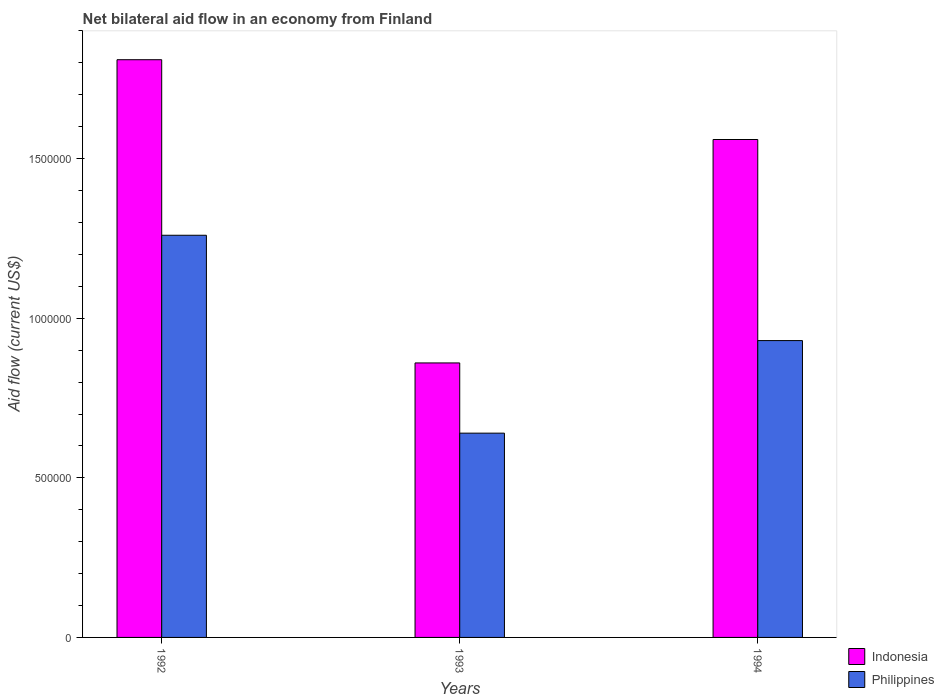How many different coloured bars are there?
Your answer should be very brief. 2. Are the number of bars on each tick of the X-axis equal?
Make the answer very short. Yes. How many bars are there on the 3rd tick from the left?
Offer a very short reply. 2. How many bars are there on the 2nd tick from the right?
Your answer should be compact. 2. What is the label of the 1st group of bars from the left?
Your answer should be very brief. 1992. What is the net bilateral aid flow in Indonesia in 1994?
Provide a succinct answer. 1.56e+06. Across all years, what is the maximum net bilateral aid flow in Philippines?
Your answer should be very brief. 1.26e+06. Across all years, what is the minimum net bilateral aid flow in Indonesia?
Make the answer very short. 8.60e+05. In which year was the net bilateral aid flow in Philippines minimum?
Offer a very short reply. 1993. What is the total net bilateral aid flow in Indonesia in the graph?
Give a very brief answer. 4.23e+06. What is the difference between the net bilateral aid flow in Philippines in 1992 and that in 1993?
Give a very brief answer. 6.20e+05. What is the average net bilateral aid flow in Indonesia per year?
Give a very brief answer. 1.41e+06. In the year 1993, what is the difference between the net bilateral aid flow in Philippines and net bilateral aid flow in Indonesia?
Offer a terse response. -2.20e+05. What is the ratio of the net bilateral aid flow in Indonesia in 1992 to that in 1994?
Provide a short and direct response. 1.16. Is the difference between the net bilateral aid flow in Philippines in 1993 and 1994 greater than the difference between the net bilateral aid flow in Indonesia in 1993 and 1994?
Your answer should be compact. Yes. What is the difference between the highest and the second highest net bilateral aid flow in Philippines?
Your answer should be very brief. 3.30e+05. What is the difference between the highest and the lowest net bilateral aid flow in Philippines?
Keep it short and to the point. 6.20e+05. In how many years, is the net bilateral aid flow in Philippines greater than the average net bilateral aid flow in Philippines taken over all years?
Your answer should be compact. 1. Is the sum of the net bilateral aid flow in Philippines in 1992 and 1993 greater than the maximum net bilateral aid flow in Indonesia across all years?
Your response must be concise. Yes. What does the 1st bar from the right in 1993 represents?
Offer a terse response. Philippines. How many bars are there?
Your answer should be compact. 6. Are the values on the major ticks of Y-axis written in scientific E-notation?
Your response must be concise. No. Does the graph contain any zero values?
Offer a very short reply. No. Does the graph contain grids?
Give a very brief answer. No. What is the title of the graph?
Your response must be concise. Net bilateral aid flow in an economy from Finland. Does "Macao" appear as one of the legend labels in the graph?
Provide a succinct answer. No. What is the label or title of the X-axis?
Keep it short and to the point. Years. What is the label or title of the Y-axis?
Provide a short and direct response. Aid flow (current US$). What is the Aid flow (current US$) of Indonesia in 1992?
Your response must be concise. 1.81e+06. What is the Aid flow (current US$) in Philippines in 1992?
Your response must be concise. 1.26e+06. What is the Aid flow (current US$) in Indonesia in 1993?
Your answer should be compact. 8.60e+05. What is the Aid flow (current US$) in Philippines in 1993?
Your response must be concise. 6.40e+05. What is the Aid flow (current US$) of Indonesia in 1994?
Keep it short and to the point. 1.56e+06. What is the Aid flow (current US$) of Philippines in 1994?
Your answer should be very brief. 9.30e+05. Across all years, what is the maximum Aid flow (current US$) in Indonesia?
Provide a succinct answer. 1.81e+06. Across all years, what is the maximum Aid flow (current US$) in Philippines?
Your response must be concise. 1.26e+06. Across all years, what is the minimum Aid flow (current US$) in Indonesia?
Offer a terse response. 8.60e+05. Across all years, what is the minimum Aid flow (current US$) of Philippines?
Ensure brevity in your answer.  6.40e+05. What is the total Aid flow (current US$) in Indonesia in the graph?
Provide a succinct answer. 4.23e+06. What is the total Aid flow (current US$) of Philippines in the graph?
Provide a short and direct response. 2.83e+06. What is the difference between the Aid flow (current US$) of Indonesia in 1992 and that in 1993?
Ensure brevity in your answer.  9.50e+05. What is the difference between the Aid flow (current US$) in Philippines in 1992 and that in 1993?
Your answer should be compact. 6.20e+05. What is the difference between the Aid flow (current US$) in Indonesia in 1992 and that in 1994?
Provide a short and direct response. 2.50e+05. What is the difference between the Aid flow (current US$) in Indonesia in 1993 and that in 1994?
Provide a short and direct response. -7.00e+05. What is the difference between the Aid flow (current US$) of Indonesia in 1992 and the Aid flow (current US$) of Philippines in 1993?
Keep it short and to the point. 1.17e+06. What is the difference between the Aid flow (current US$) in Indonesia in 1992 and the Aid flow (current US$) in Philippines in 1994?
Your answer should be very brief. 8.80e+05. What is the difference between the Aid flow (current US$) of Indonesia in 1993 and the Aid flow (current US$) of Philippines in 1994?
Provide a succinct answer. -7.00e+04. What is the average Aid flow (current US$) in Indonesia per year?
Offer a very short reply. 1.41e+06. What is the average Aid flow (current US$) of Philippines per year?
Your answer should be compact. 9.43e+05. In the year 1992, what is the difference between the Aid flow (current US$) in Indonesia and Aid flow (current US$) in Philippines?
Offer a very short reply. 5.50e+05. In the year 1993, what is the difference between the Aid flow (current US$) of Indonesia and Aid flow (current US$) of Philippines?
Give a very brief answer. 2.20e+05. In the year 1994, what is the difference between the Aid flow (current US$) of Indonesia and Aid flow (current US$) of Philippines?
Ensure brevity in your answer.  6.30e+05. What is the ratio of the Aid flow (current US$) of Indonesia in 1992 to that in 1993?
Offer a very short reply. 2.1. What is the ratio of the Aid flow (current US$) in Philippines in 1992 to that in 1993?
Your response must be concise. 1.97. What is the ratio of the Aid flow (current US$) of Indonesia in 1992 to that in 1994?
Keep it short and to the point. 1.16. What is the ratio of the Aid flow (current US$) of Philippines in 1992 to that in 1994?
Your answer should be very brief. 1.35. What is the ratio of the Aid flow (current US$) in Indonesia in 1993 to that in 1994?
Your answer should be compact. 0.55. What is the ratio of the Aid flow (current US$) in Philippines in 1993 to that in 1994?
Make the answer very short. 0.69. What is the difference between the highest and the second highest Aid flow (current US$) of Indonesia?
Your response must be concise. 2.50e+05. What is the difference between the highest and the lowest Aid flow (current US$) in Indonesia?
Offer a very short reply. 9.50e+05. What is the difference between the highest and the lowest Aid flow (current US$) of Philippines?
Your response must be concise. 6.20e+05. 